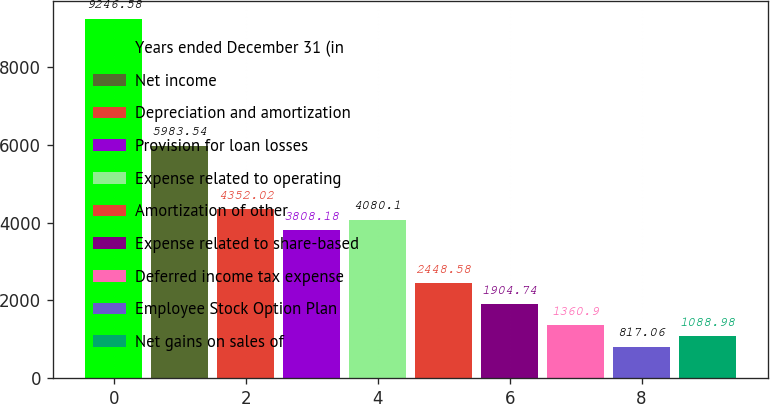Convert chart to OTSL. <chart><loc_0><loc_0><loc_500><loc_500><bar_chart><fcel>Years ended December 31 (in<fcel>Net income<fcel>Depreciation and amortization<fcel>Provision for loan losses<fcel>Expense related to operating<fcel>Amortization of other<fcel>Expense related to share-based<fcel>Deferred income tax expense<fcel>Employee Stock Option Plan<fcel>Net gains on sales of<nl><fcel>9246.58<fcel>5983.54<fcel>4352.02<fcel>3808.18<fcel>4080.1<fcel>2448.58<fcel>1904.74<fcel>1360.9<fcel>817.06<fcel>1088.98<nl></chart> 